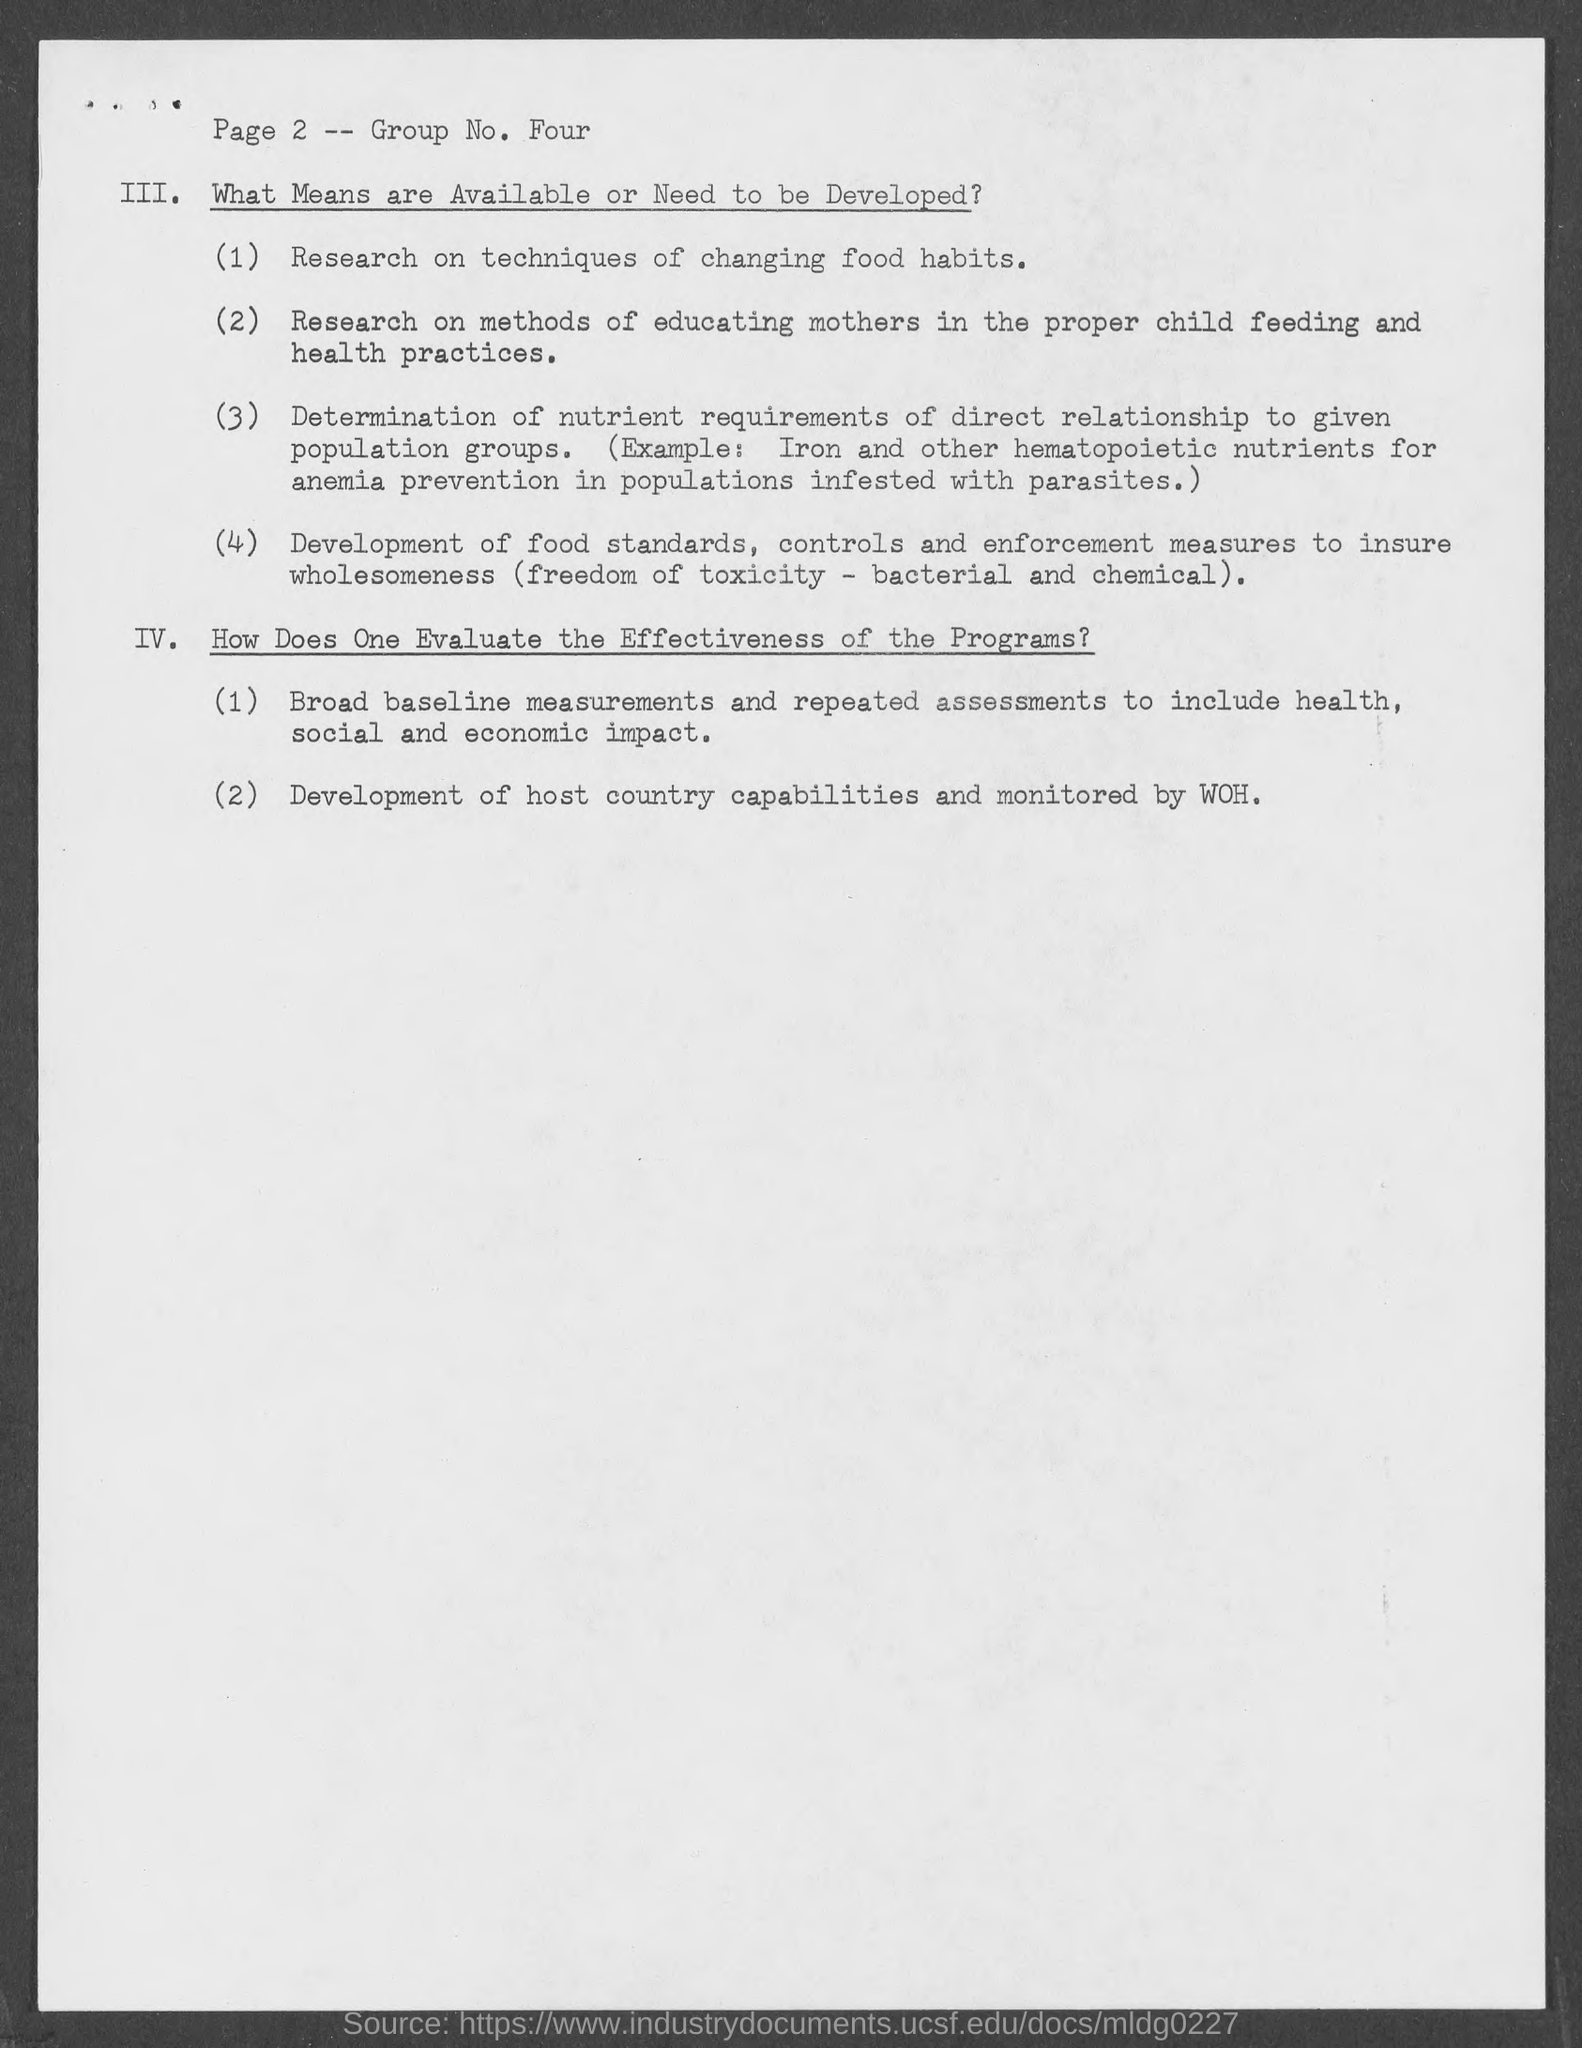What is the page number mentioned in the document ?
Provide a short and direct response. 2. What is the group no. mentioned in document?
Offer a terse response. Four. Development of host country capabilities and monitored by?
Your response must be concise. WOH. 